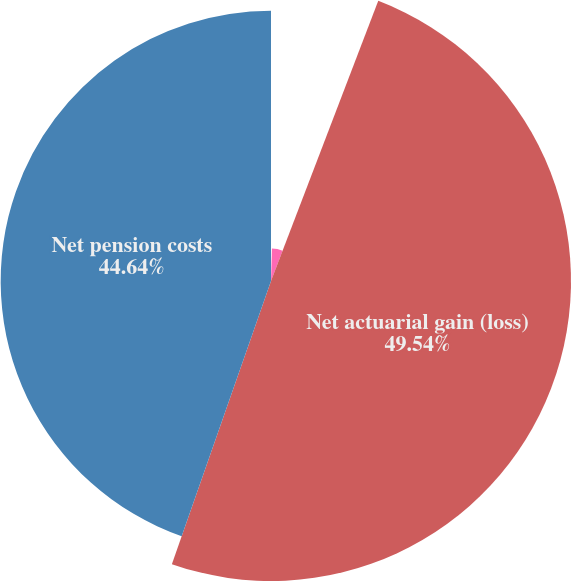Convert chart. <chart><loc_0><loc_0><loc_500><loc_500><pie_chart><fcel>Amortization of prior service<fcel>Amortization of net actuarial<fcel>Net actuarial gain (loss)<fcel>Net pension costs<nl><fcel>0.46%<fcel>5.36%<fcel>49.54%<fcel>44.64%<nl></chart> 